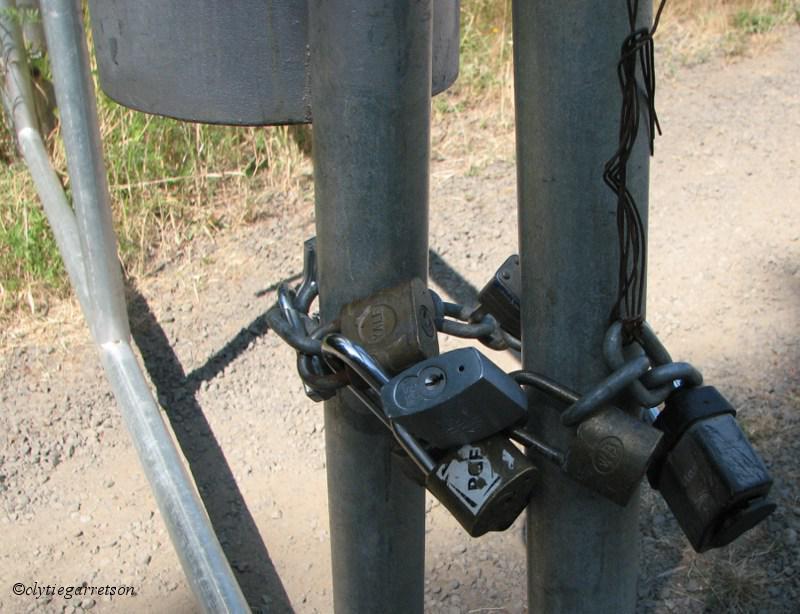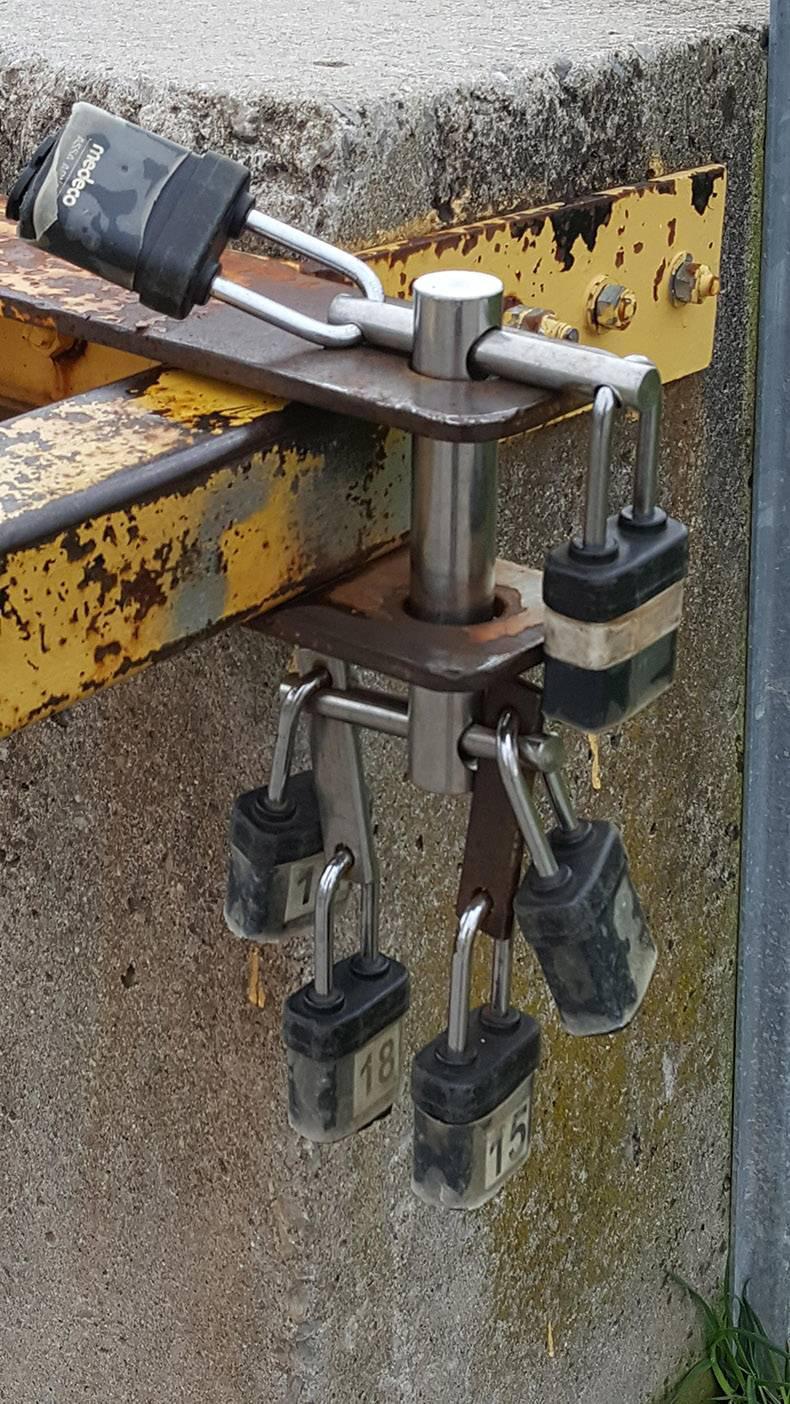The first image is the image on the left, the second image is the image on the right. Given the left and right images, does the statement "In one of the images, the locks are seen placed on something other than a metal fence." hold true? Answer yes or no. Yes. The first image is the image on the left, the second image is the image on the right. Considering the images on both sides, is "At least one image contains no less than six locks." valid? Answer yes or no. Yes. 